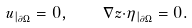<formula> <loc_0><loc_0><loc_500><loc_500>u _ { | _ { \partial \Omega } } = 0 , \quad \nabla z { \cdot } \eta _ { | _ { \partial \Omega } } = 0 .</formula> 